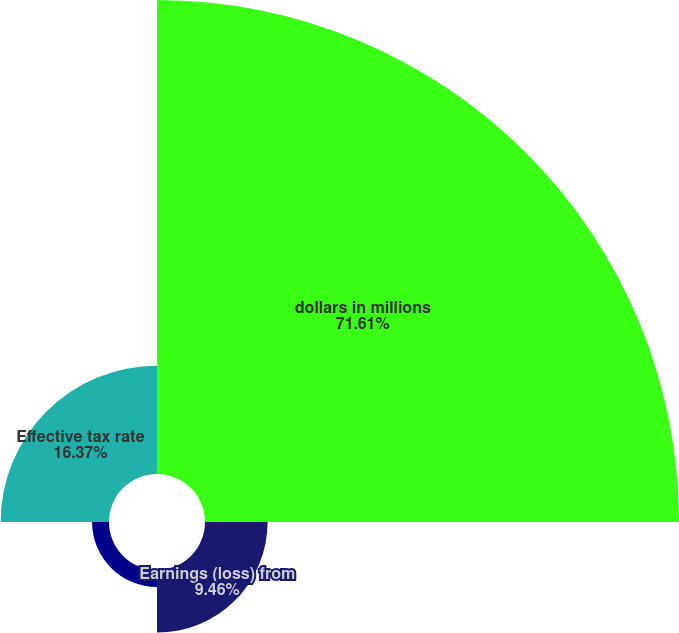<chart> <loc_0><loc_0><loc_500><loc_500><pie_chart><fcel>dollars in millions<fcel>Earnings (loss) from<fcel>Provision (benefit) for income<fcel>Effective tax rate<nl><fcel>71.61%<fcel>9.46%<fcel>2.56%<fcel>16.37%<nl></chart> 